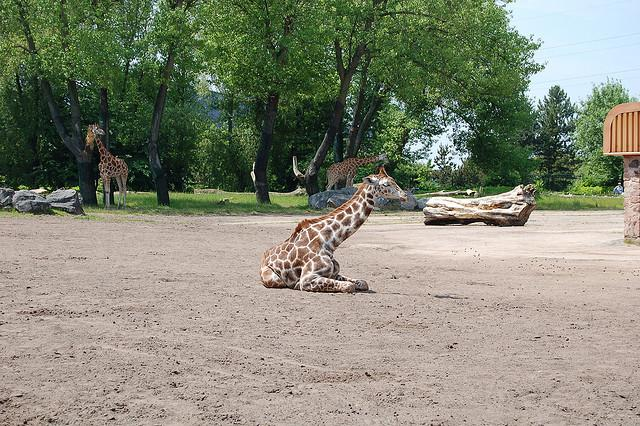What us the giraffe in the foreground sitting on? Please explain your reasoning. sand. The other options don't make sense given the season or appear in this image. 